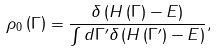Convert formula to latex. <formula><loc_0><loc_0><loc_500><loc_500>\rho _ { 0 } \left ( \Gamma \right ) = { \frac { \delta \left ( H \left ( \Gamma \right ) - E \right ) } { \int d \Gamma ^ { \prime } \delta \left ( H \left ( \Gamma ^ { \prime } \right ) - E \right ) } } ,</formula> 